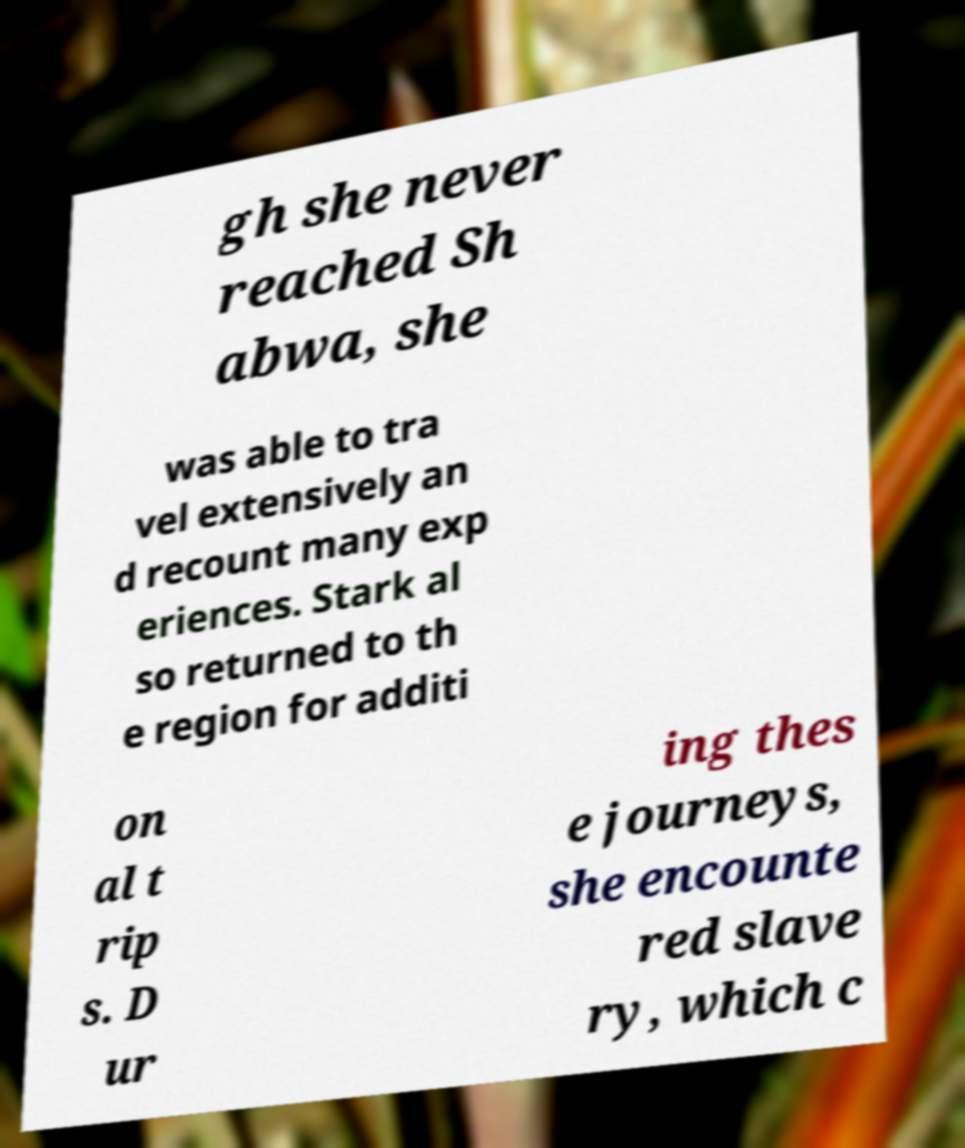What messages or text are displayed in this image? I need them in a readable, typed format. gh she never reached Sh abwa, she was able to tra vel extensively an d recount many exp eriences. Stark al so returned to th e region for additi on al t rip s. D ur ing thes e journeys, she encounte red slave ry, which c 